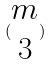<formula> <loc_0><loc_0><loc_500><loc_500>( \begin{matrix} m \\ 3 \end{matrix} )</formula> 